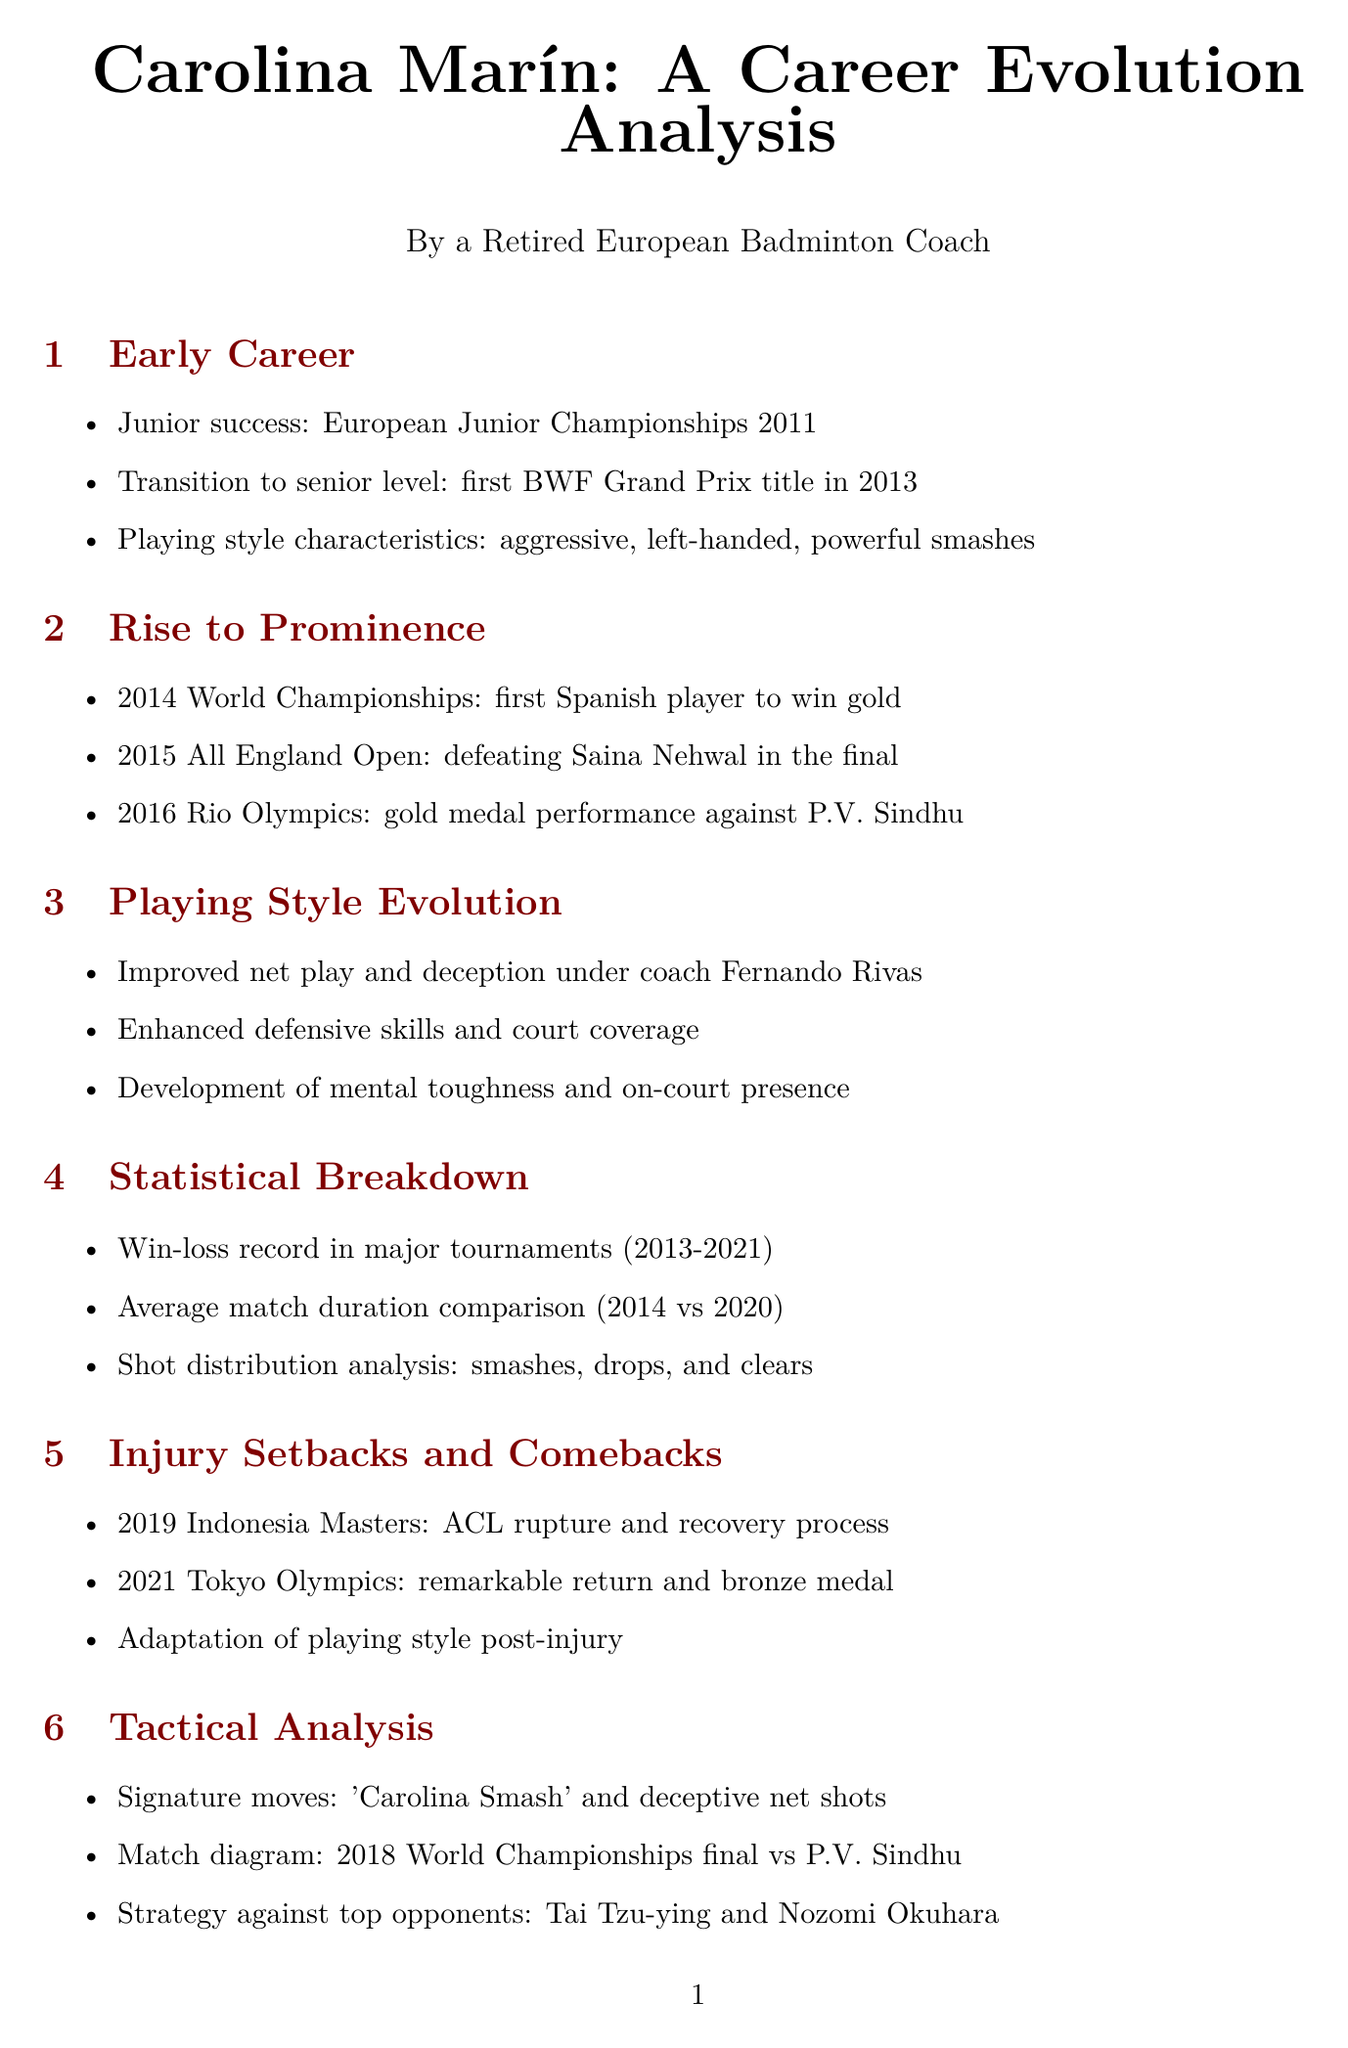What year did Carolina Marín win her first BWF Grand Prix title? The document states that Carolina Marín won her first BWF Grand Prix title in 2013.
Answer: 2013 How many World Championships titles has Carolina Marín won? According to the document, Carolina Marín has won 3 World Championships titles.
Answer: 3 What is the score of the 2016 Rio Olympics final between Carolina Marín and P.V. Sindhu? The document provides the score as 19-21, 21-12, 21-15 for the final match.
Answer: 19-21, 21-12, 21-15 Who trained Carolina Marín to improve her net play? The document mentions that coach Fernando Rivas helped improve Carolina Marín's net play.
Answer: Fernando Rivas What is Carolina Marín's career win percentage overall? The document states that her overall career win percentage is 73.2%.
Answer: 73.2% What type of injury did Carolina Marín suffer in 2019? The document specifies that she suffered an ACL rupture at the 2019 Indonesia Masters.
Answer: ACL rupture How many European Championships has Carolina Marín won? The document states that she has won 5 European Championships titles.
Answer: 5 Which player did Carolina Marín defeat in the 2015 All England Open final? The document notes that she defeated Saina Nehwal in the final.
Answer: Saina Nehwal In what event did Carolina Marín achieve a remarkable return after her injury? The document states that she made a remarkable return at the 2021 Tokyo Olympics.
Answer: 2021 Tokyo Olympics 